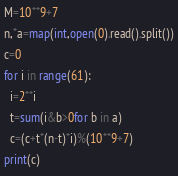<code> <loc_0><loc_0><loc_500><loc_500><_Python_>M=10**9+7
n,*a=map(int,open(0).read().split())
c=0
for i in range(61):
  i=2**i
  t=sum(i&b>0for b in a)
  c=(c+t*(n-t)*i)%(10**9+7)
print(c)</code> 